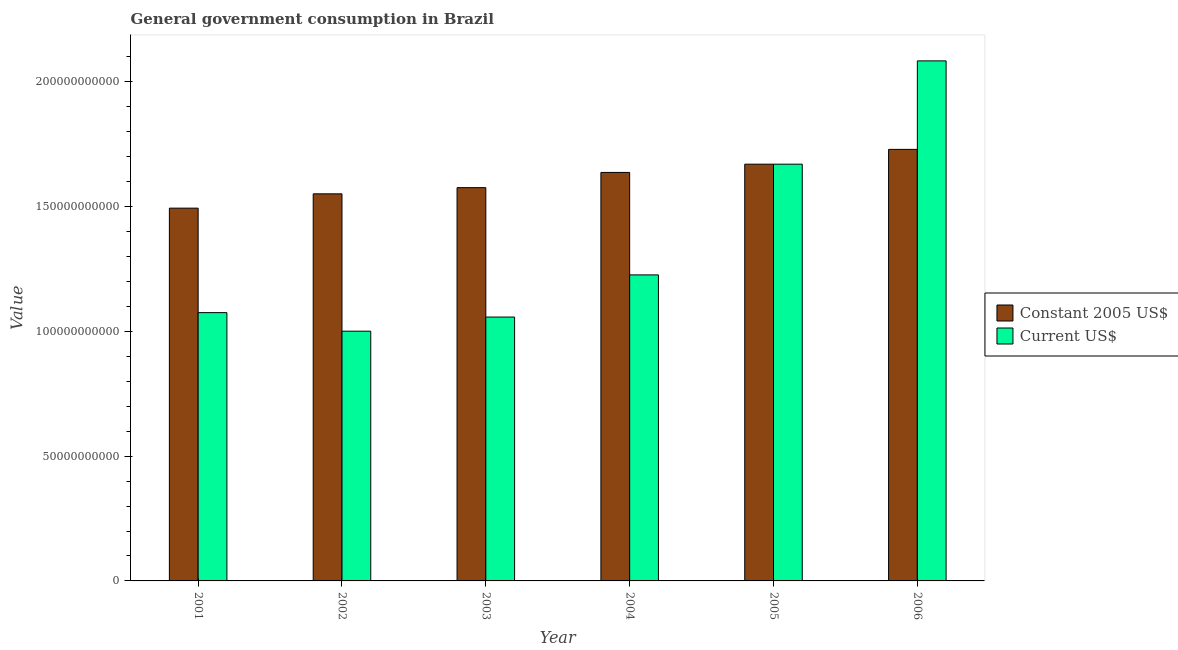How many different coloured bars are there?
Give a very brief answer. 2. Are the number of bars per tick equal to the number of legend labels?
Your answer should be very brief. Yes. Are the number of bars on each tick of the X-axis equal?
Your response must be concise. Yes. How many bars are there on the 6th tick from the left?
Give a very brief answer. 2. How many bars are there on the 5th tick from the right?
Make the answer very short. 2. What is the value consumed in current us$ in 2004?
Provide a succinct answer. 1.23e+11. Across all years, what is the maximum value consumed in current us$?
Provide a succinct answer. 2.08e+11. Across all years, what is the minimum value consumed in current us$?
Provide a succinct answer. 1.00e+11. What is the total value consumed in current us$ in the graph?
Make the answer very short. 8.11e+11. What is the difference between the value consumed in constant 2005 us$ in 2003 and that in 2005?
Your answer should be compact. -9.41e+09. What is the difference between the value consumed in constant 2005 us$ in 2003 and the value consumed in current us$ in 2004?
Keep it short and to the point. -6.10e+09. What is the average value consumed in current us$ per year?
Offer a very short reply. 1.35e+11. In how many years, is the value consumed in constant 2005 us$ greater than 180000000000?
Your answer should be very brief. 0. What is the ratio of the value consumed in current us$ in 2003 to that in 2005?
Offer a very short reply. 0.63. Is the difference between the value consumed in constant 2005 us$ in 2001 and 2004 greater than the difference between the value consumed in current us$ in 2001 and 2004?
Give a very brief answer. No. What is the difference between the highest and the second highest value consumed in current us$?
Make the answer very short. 4.14e+1. What is the difference between the highest and the lowest value consumed in constant 2005 us$?
Ensure brevity in your answer.  2.36e+1. Is the sum of the value consumed in constant 2005 us$ in 2004 and 2006 greater than the maximum value consumed in current us$ across all years?
Your answer should be compact. Yes. What does the 2nd bar from the left in 2004 represents?
Keep it short and to the point. Current US$. What does the 1st bar from the right in 2005 represents?
Your answer should be very brief. Current US$. Are the values on the major ticks of Y-axis written in scientific E-notation?
Your response must be concise. No. Does the graph contain any zero values?
Keep it short and to the point. No. Where does the legend appear in the graph?
Give a very brief answer. Center right. How are the legend labels stacked?
Make the answer very short. Vertical. What is the title of the graph?
Make the answer very short. General government consumption in Brazil. Does "Short-term debt" appear as one of the legend labels in the graph?
Your response must be concise. No. What is the label or title of the X-axis?
Offer a terse response. Year. What is the label or title of the Y-axis?
Make the answer very short. Value. What is the Value in Constant 2005 US$ in 2001?
Ensure brevity in your answer.  1.49e+11. What is the Value of Current US$ in 2001?
Give a very brief answer. 1.08e+11. What is the Value of Constant 2005 US$ in 2002?
Make the answer very short. 1.55e+11. What is the Value of Current US$ in 2002?
Give a very brief answer. 1.00e+11. What is the Value in Constant 2005 US$ in 2003?
Your response must be concise. 1.58e+11. What is the Value of Current US$ in 2003?
Make the answer very short. 1.06e+11. What is the Value in Constant 2005 US$ in 2004?
Your response must be concise. 1.64e+11. What is the Value of Current US$ in 2004?
Offer a terse response. 1.23e+11. What is the Value of Constant 2005 US$ in 2005?
Your response must be concise. 1.67e+11. What is the Value in Current US$ in 2005?
Make the answer very short. 1.67e+11. What is the Value in Constant 2005 US$ in 2006?
Give a very brief answer. 1.73e+11. What is the Value of Current US$ in 2006?
Keep it short and to the point. 2.08e+11. Across all years, what is the maximum Value in Constant 2005 US$?
Provide a succinct answer. 1.73e+11. Across all years, what is the maximum Value of Current US$?
Your response must be concise. 2.08e+11. Across all years, what is the minimum Value of Constant 2005 US$?
Give a very brief answer. 1.49e+11. Across all years, what is the minimum Value of Current US$?
Keep it short and to the point. 1.00e+11. What is the total Value of Constant 2005 US$ in the graph?
Your response must be concise. 9.66e+11. What is the total Value in Current US$ in the graph?
Provide a succinct answer. 8.11e+11. What is the difference between the Value of Constant 2005 US$ in 2001 and that in 2002?
Give a very brief answer. -5.73e+09. What is the difference between the Value of Current US$ in 2001 and that in 2002?
Provide a short and direct response. 7.43e+09. What is the difference between the Value of Constant 2005 US$ in 2001 and that in 2003?
Your response must be concise. -8.21e+09. What is the difference between the Value in Current US$ in 2001 and that in 2003?
Your answer should be compact. 1.77e+09. What is the difference between the Value in Constant 2005 US$ in 2001 and that in 2004?
Ensure brevity in your answer.  -1.43e+1. What is the difference between the Value of Current US$ in 2001 and that in 2004?
Make the answer very short. -1.51e+1. What is the difference between the Value of Constant 2005 US$ in 2001 and that in 2005?
Provide a short and direct response. -1.76e+1. What is the difference between the Value in Current US$ in 2001 and that in 2005?
Your response must be concise. -5.95e+1. What is the difference between the Value of Constant 2005 US$ in 2001 and that in 2006?
Ensure brevity in your answer.  -2.36e+1. What is the difference between the Value in Current US$ in 2001 and that in 2006?
Offer a terse response. -1.01e+11. What is the difference between the Value in Constant 2005 US$ in 2002 and that in 2003?
Offer a terse response. -2.48e+09. What is the difference between the Value of Current US$ in 2002 and that in 2003?
Offer a terse response. -5.66e+09. What is the difference between the Value in Constant 2005 US$ in 2002 and that in 2004?
Offer a very short reply. -8.58e+09. What is the difference between the Value in Current US$ in 2002 and that in 2004?
Your answer should be very brief. -2.26e+1. What is the difference between the Value in Constant 2005 US$ in 2002 and that in 2005?
Make the answer very short. -1.19e+1. What is the difference between the Value in Current US$ in 2002 and that in 2005?
Your response must be concise. -6.69e+1. What is the difference between the Value in Constant 2005 US$ in 2002 and that in 2006?
Your answer should be very brief. -1.78e+1. What is the difference between the Value of Current US$ in 2002 and that in 2006?
Make the answer very short. -1.08e+11. What is the difference between the Value of Constant 2005 US$ in 2003 and that in 2004?
Keep it short and to the point. -6.10e+09. What is the difference between the Value of Current US$ in 2003 and that in 2004?
Offer a terse response. -1.69e+1. What is the difference between the Value of Constant 2005 US$ in 2003 and that in 2005?
Make the answer very short. -9.41e+09. What is the difference between the Value of Current US$ in 2003 and that in 2005?
Your response must be concise. -6.13e+1. What is the difference between the Value of Constant 2005 US$ in 2003 and that in 2006?
Offer a terse response. -1.53e+1. What is the difference between the Value of Current US$ in 2003 and that in 2006?
Your response must be concise. -1.03e+11. What is the difference between the Value in Constant 2005 US$ in 2004 and that in 2005?
Provide a short and direct response. -3.31e+09. What is the difference between the Value of Current US$ in 2004 and that in 2005?
Keep it short and to the point. -4.44e+1. What is the difference between the Value in Constant 2005 US$ in 2004 and that in 2006?
Offer a terse response. -9.24e+09. What is the difference between the Value of Current US$ in 2004 and that in 2006?
Ensure brevity in your answer.  -8.58e+1. What is the difference between the Value of Constant 2005 US$ in 2005 and that in 2006?
Your answer should be very brief. -5.93e+09. What is the difference between the Value of Current US$ in 2005 and that in 2006?
Your answer should be very brief. -4.14e+1. What is the difference between the Value of Constant 2005 US$ in 2001 and the Value of Current US$ in 2002?
Give a very brief answer. 4.93e+1. What is the difference between the Value in Constant 2005 US$ in 2001 and the Value in Current US$ in 2003?
Offer a very short reply. 4.36e+1. What is the difference between the Value in Constant 2005 US$ in 2001 and the Value in Current US$ in 2004?
Give a very brief answer. 2.68e+1. What is the difference between the Value of Constant 2005 US$ in 2001 and the Value of Current US$ in 2005?
Provide a succinct answer. -1.76e+1. What is the difference between the Value in Constant 2005 US$ in 2001 and the Value in Current US$ in 2006?
Offer a very short reply. -5.90e+1. What is the difference between the Value in Constant 2005 US$ in 2002 and the Value in Current US$ in 2003?
Your response must be concise. 4.94e+1. What is the difference between the Value in Constant 2005 US$ in 2002 and the Value in Current US$ in 2004?
Your answer should be very brief. 3.25e+1. What is the difference between the Value of Constant 2005 US$ in 2002 and the Value of Current US$ in 2005?
Make the answer very short. -1.19e+1. What is the difference between the Value in Constant 2005 US$ in 2002 and the Value in Current US$ in 2006?
Offer a terse response. -5.33e+1. What is the difference between the Value in Constant 2005 US$ in 2003 and the Value in Current US$ in 2004?
Offer a terse response. 3.50e+1. What is the difference between the Value of Constant 2005 US$ in 2003 and the Value of Current US$ in 2005?
Give a very brief answer. -9.41e+09. What is the difference between the Value in Constant 2005 US$ in 2003 and the Value in Current US$ in 2006?
Ensure brevity in your answer.  -5.08e+1. What is the difference between the Value of Constant 2005 US$ in 2004 and the Value of Current US$ in 2005?
Your answer should be very brief. -3.31e+09. What is the difference between the Value of Constant 2005 US$ in 2004 and the Value of Current US$ in 2006?
Provide a short and direct response. -4.47e+1. What is the difference between the Value of Constant 2005 US$ in 2005 and the Value of Current US$ in 2006?
Your response must be concise. -4.14e+1. What is the average Value in Constant 2005 US$ per year?
Offer a terse response. 1.61e+11. What is the average Value of Current US$ per year?
Ensure brevity in your answer.  1.35e+11. In the year 2001, what is the difference between the Value of Constant 2005 US$ and Value of Current US$?
Your response must be concise. 4.19e+1. In the year 2002, what is the difference between the Value in Constant 2005 US$ and Value in Current US$?
Give a very brief answer. 5.50e+1. In the year 2003, what is the difference between the Value in Constant 2005 US$ and Value in Current US$?
Your response must be concise. 5.19e+1. In the year 2004, what is the difference between the Value of Constant 2005 US$ and Value of Current US$?
Keep it short and to the point. 4.11e+1. In the year 2005, what is the difference between the Value of Constant 2005 US$ and Value of Current US$?
Give a very brief answer. 0. In the year 2006, what is the difference between the Value in Constant 2005 US$ and Value in Current US$?
Your answer should be compact. -3.55e+1. What is the ratio of the Value in Current US$ in 2001 to that in 2002?
Your response must be concise. 1.07. What is the ratio of the Value in Constant 2005 US$ in 2001 to that in 2003?
Make the answer very short. 0.95. What is the ratio of the Value of Current US$ in 2001 to that in 2003?
Your answer should be very brief. 1.02. What is the ratio of the Value in Constant 2005 US$ in 2001 to that in 2004?
Provide a succinct answer. 0.91. What is the ratio of the Value of Current US$ in 2001 to that in 2004?
Offer a very short reply. 0.88. What is the ratio of the Value in Constant 2005 US$ in 2001 to that in 2005?
Ensure brevity in your answer.  0.89. What is the ratio of the Value in Current US$ in 2001 to that in 2005?
Make the answer very short. 0.64. What is the ratio of the Value in Constant 2005 US$ in 2001 to that in 2006?
Ensure brevity in your answer.  0.86. What is the ratio of the Value in Current US$ in 2001 to that in 2006?
Provide a succinct answer. 0.52. What is the ratio of the Value in Constant 2005 US$ in 2002 to that in 2003?
Offer a very short reply. 0.98. What is the ratio of the Value in Current US$ in 2002 to that in 2003?
Ensure brevity in your answer.  0.95. What is the ratio of the Value in Constant 2005 US$ in 2002 to that in 2004?
Keep it short and to the point. 0.95. What is the ratio of the Value of Current US$ in 2002 to that in 2004?
Give a very brief answer. 0.82. What is the ratio of the Value in Constant 2005 US$ in 2002 to that in 2005?
Your response must be concise. 0.93. What is the ratio of the Value in Current US$ in 2002 to that in 2005?
Provide a short and direct response. 0.6. What is the ratio of the Value of Constant 2005 US$ in 2002 to that in 2006?
Give a very brief answer. 0.9. What is the ratio of the Value of Current US$ in 2002 to that in 2006?
Offer a very short reply. 0.48. What is the ratio of the Value of Constant 2005 US$ in 2003 to that in 2004?
Make the answer very short. 0.96. What is the ratio of the Value in Current US$ in 2003 to that in 2004?
Your answer should be compact. 0.86. What is the ratio of the Value in Constant 2005 US$ in 2003 to that in 2005?
Your response must be concise. 0.94. What is the ratio of the Value of Current US$ in 2003 to that in 2005?
Your answer should be compact. 0.63. What is the ratio of the Value in Constant 2005 US$ in 2003 to that in 2006?
Give a very brief answer. 0.91. What is the ratio of the Value in Current US$ in 2003 to that in 2006?
Your answer should be very brief. 0.51. What is the ratio of the Value of Constant 2005 US$ in 2004 to that in 2005?
Offer a terse response. 0.98. What is the ratio of the Value in Current US$ in 2004 to that in 2005?
Ensure brevity in your answer.  0.73. What is the ratio of the Value of Constant 2005 US$ in 2004 to that in 2006?
Offer a terse response. 0.95. What is the ratio of the Value in Current US$ in 2004 to that in 2006?
Your answer should be compact. 0.59. What is the ratio of the Value of Constant 2005 US$ in 2005 to that in 2006?
Your answer should be compact. 0.97. What is the ratio of the Value in Current US$ in 2005 to that in 2006?
Provide a short and direct response. 0.8. What is the difference between the highest and the second highest Value in Constant 2005 US$?
Give a very brief answer. 5.93e+09. What is the difference between the highest and the second highest Value of Current US$?
Your response must be concise. 4.14e+1. What is the difference between the highest and the lowest Value in Constant 2005 US$?
Make the answer very short. 2.36e+1. What is the difference between the highest and the lowest Value of Current US$?
Keep it short and to the point. 1.08e+11. 